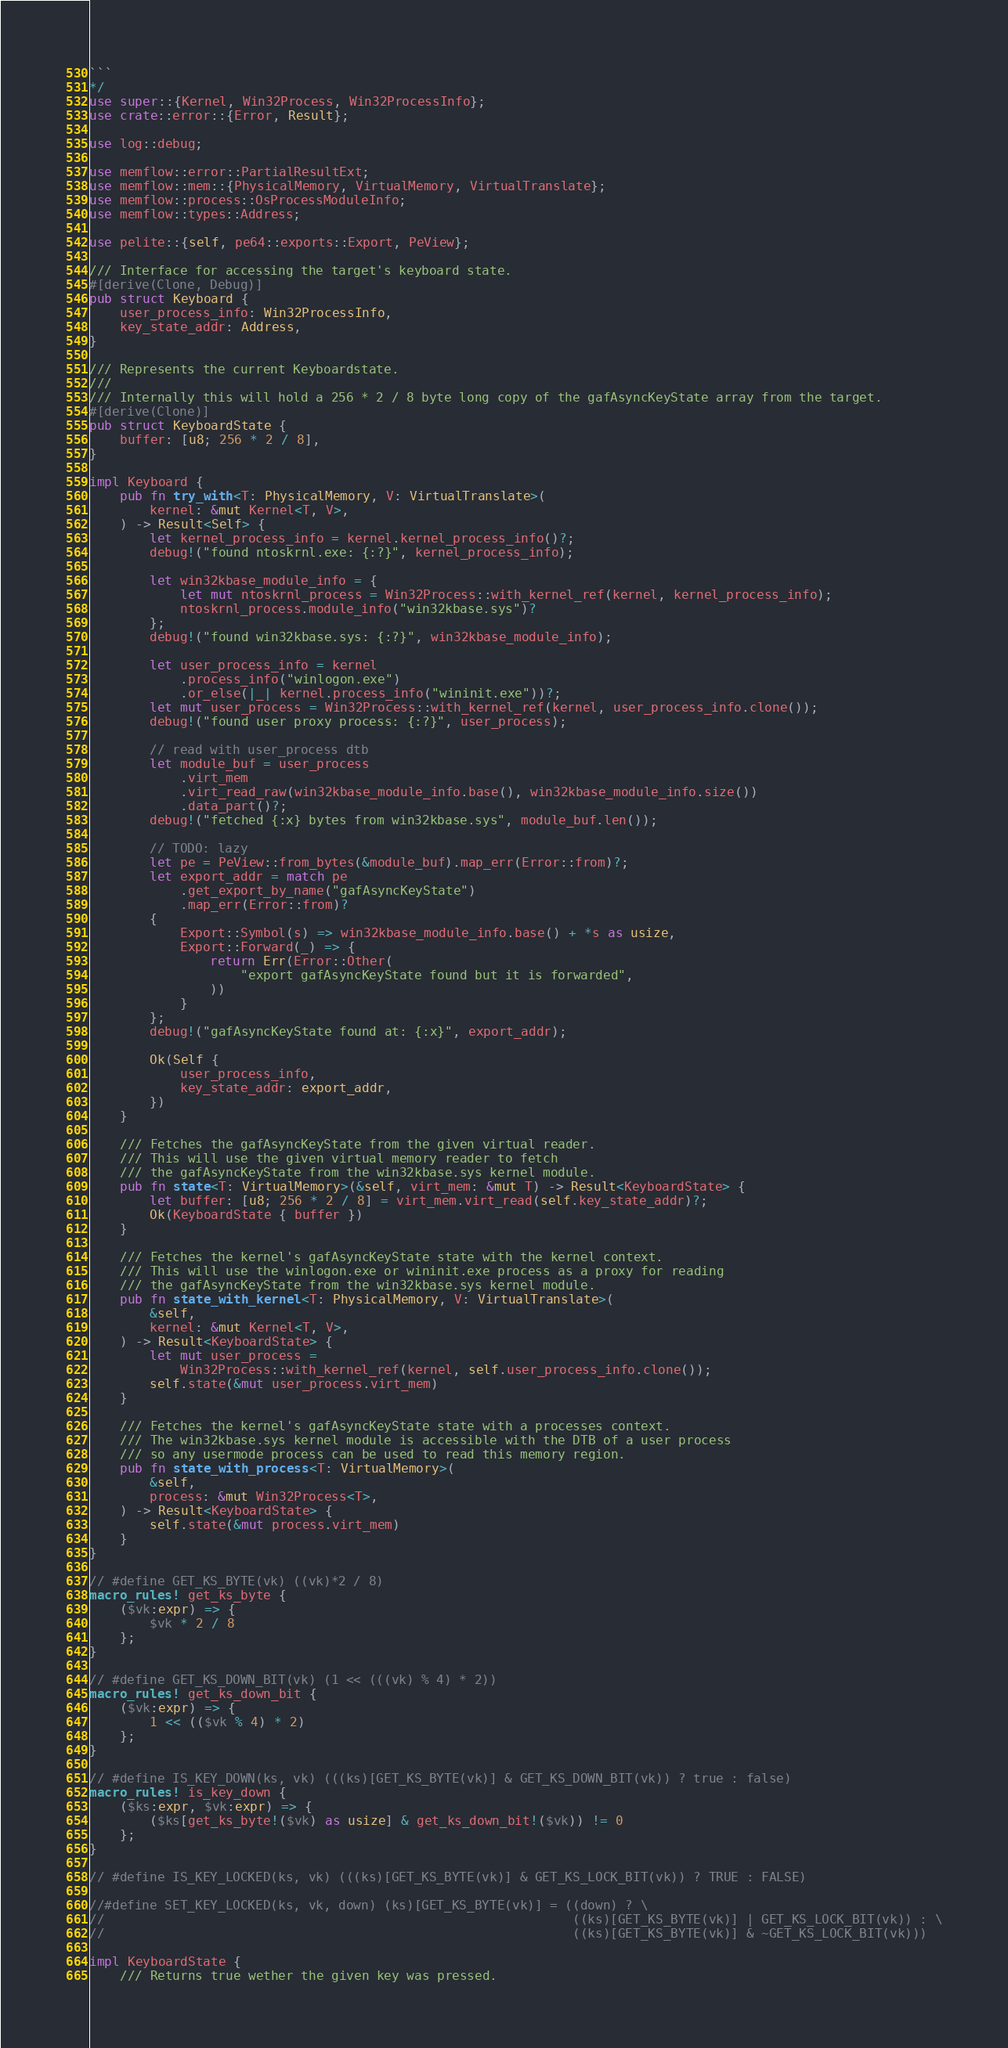Convert code to text. <code><loc_0><loc_0><loc_500><loc_500><_Rust_>```
*/
use super::{Kernel, Win32Process, Win32ProcessInfo};
use crate::error::{Error, Result};

use log::debug;

use memflow::error::PartialResultExt;
use memflow::mem::{PhysicalMemory, VirtualMemory, VirtualTranslate};
use memflow::process::OsProcessModuleInfo;
use memflow::types::Address;

use pelite::{self, pe64::exports::Export, PeView};

/// Interface for accessing the target's keyboard state.
#[derive(Clone, Debug)]
pub struct Keyboard {
    user_process_info: Win32ProcessInfo,
    key_state_addr: Address,
}

/// Represents the current Keyboardstate.
///
/// Internally this will hold a 256 * 2 / 8 byte long copy of the gafAsyncKeyState array from the target.
#[derive(Clone)]
pub struct KeyboardState {
    buffer: [u8; 256 * 2 / 8],
}

impl Keyboard {
    pub fn try_with<T: PhysicalMemory, V: VirtualTranslate>(
        kernel: &mut Kernel<T, V>,
    ) -> Result<Self> {
        let kernel_process_info = kernel.kernel_process_info()?;
        debug!("found ntoskrnl.exe: {:?}", kernel_process_info);

        let win32kbase_module_info = {
            let mut ntoskrnl_process = Win32Process::with_kernel_ref(kernel, kernel_process_info);
            ntoskrnl_process.module_info("win32kbase.sys")?
        };
        debug!("found win32kbase.sys: {:?}", win32kbase_module_info);

        let user_process_info = kernel
            .process_info("winlogon.exe")
            .or_else(|_| kernel.process_info("wininit.exe"))?;
        let mut user_process = Win32Process::with_kernel_ref(kernel, user_process_info.clone());
        debug!("found user proxy process: {:?}", user_process);

        // read with user_process dtb
        let module_buf = user_process
            .virt_mem
            .virt_read_raw(win32kbase_module_info.base(), win32kbase_module_info.size())
            .data_part()?;
        debug!("fetched {:x} bytes from win32kbase.sys", module_buf.len());

        // TODO: lazy
        let pe = PeView::from_bytes(&module_buf).map_err(Error::from)?;
        let export_addr = match pe
            .get_export_by_name("gafAsyncKeyState")
            .map_err(Error::from)?
        {
            Export::Symbol(s) => win32kbase_module_info.base() + *s as usize,
            Export::Forward(_) => {
                return Err(Error::Other(
                    "export gafAsyncKeyState found but it is forwarded",
                ))
            }
        };
        debug!("gafAsyncKeyState found at: {:x}", export_addr);

        Ok(Self {
            user_process_info,
            key_state_addr: export_addr,
        })
    }

    /// Fetches the gafAsyncKeyState from the given virtual reader.
    /// This will use the given virtual memory reader to fetch
    /// the gafAsyncKeyState from the win32kbase.sys kernel module.
    pub fn state<T: VirtualMemory>(&self, virt_mem: &mut T) -> Result<KeyboardState> {
        let buffer: [u8; 256 * 2 / 8] = virt_mem.virt_read(self.key_state_addr)?;
        Ok(KeyboardState { buffer })
    }

    /// Fetches the kernel's gafAsyncKeyState state with the kernel context.
    /// This will use the winlogon.exe or wininit.exe process as a proxy for reading
    /// the gafAsyncKeyState from the win32kbase.sys kernel module.
    pub fn state_with_kernel<T: PhysicalMemory, V: VirtualTranslate>(
        &self,
        kernel: &mut Kernel<T, V>,
    ) -> Result<KeyboardState> {
        let mut user_process =
            Win32Process::with_kernel_ref(kernel, self.user_process_info.clone());
        self.state(&mut user_process.virt_mem)
    }

    /// Fetches the kernel's gafAsyncKeyState state with a processes context.
    /// The win32kbase.sys kernel module is accessible with the DTB of a user process
    /// so any usermode process can be used to read this memory region.
    pub fn state_with_process<T: VirtualMemory>(
        &self,
        process: &mut Win32Process<T>,
    ) -> Result<KeyboardState> {
        self.state(&mut process.virt_mem)
    }
}

// #define GET_KS_BYTE(vk) ((vk)*2 / 8)
macro_rules! get_ks_byte {
    ($vk:expr) => {
        $vk * 2 / 8
    };
}

// #define GET_KS_DOWN_BIT(vk) (1 << (((vk) % 4) * 2))
macro_rules! get_ks_down_bit {
    ($vk:expr) => {
        1 << (($vk % 4) * 2)
    };
}

// #define IS_KEY_DOWN(ks, vk) (((ks)[GET_KS_BYTE(vk)] & GET_KS_DOWN_BIT(vk)) ? true : false)
macro_rules! is_key_down {
    ($ks:expr, $vk:expr) => {
        ($ks[get_ks_byte!($vk) as usize] & get_ks_down_bit!($vk)) != 0
    };
}

// #define IS_KEY_LOCKED(ks, vk) (((ks)[GET_KS_BYTE(vk)] & GET_KS_LOCK_BIT(vk)) ? TRUE : FALSE)

//#define SET_KEY_LOCKED(ks, vk, down) (ks)[GET_KS_BYTE(vk)] = ((down) ? \
//                                                              ((ks)[GET_KS_BYTE(vk)] | GET_KS_LOCK_BIT(vk)) : \
//                                                              ((ks)[GET_KS_BYTE(vk)] & ~GET_KS_LOCK_BIT(vk)))

impl KeyboardState {
    /// Returns true wether the given key was pressed.</code> 